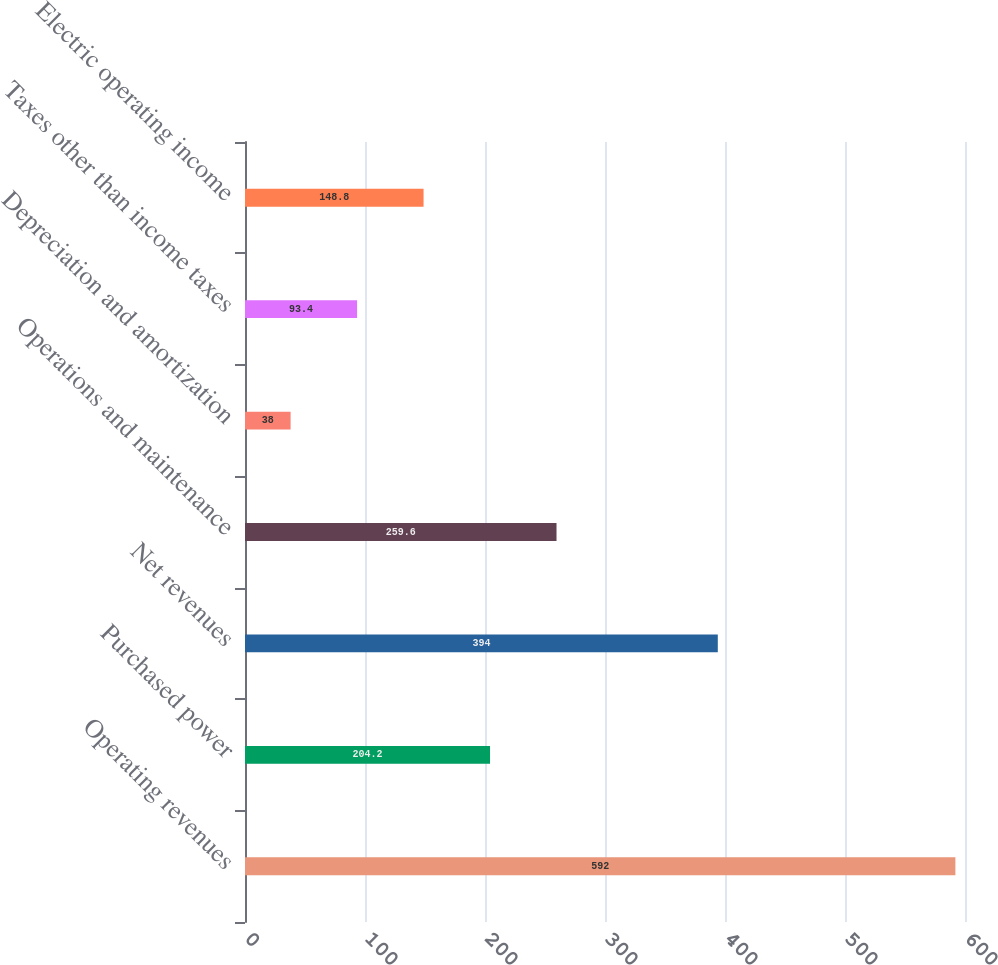Convert chart. <chart><loc_0><loc_0><loc_500><loc_500><bar_chart><fcel>Operating revenues<fcel>Purchased power<fcel>Net revenues<fcel>Operations and maintenance<fcel>Depreciation and amortization<fcel>Taxes other than income taxes<fcel>Electric operating income<nl><fcel>592<fcel>204.2<fcel>394<fcel>259.6<fcel>38<fcel>93.4<fcel>148.8<nl></chart> 